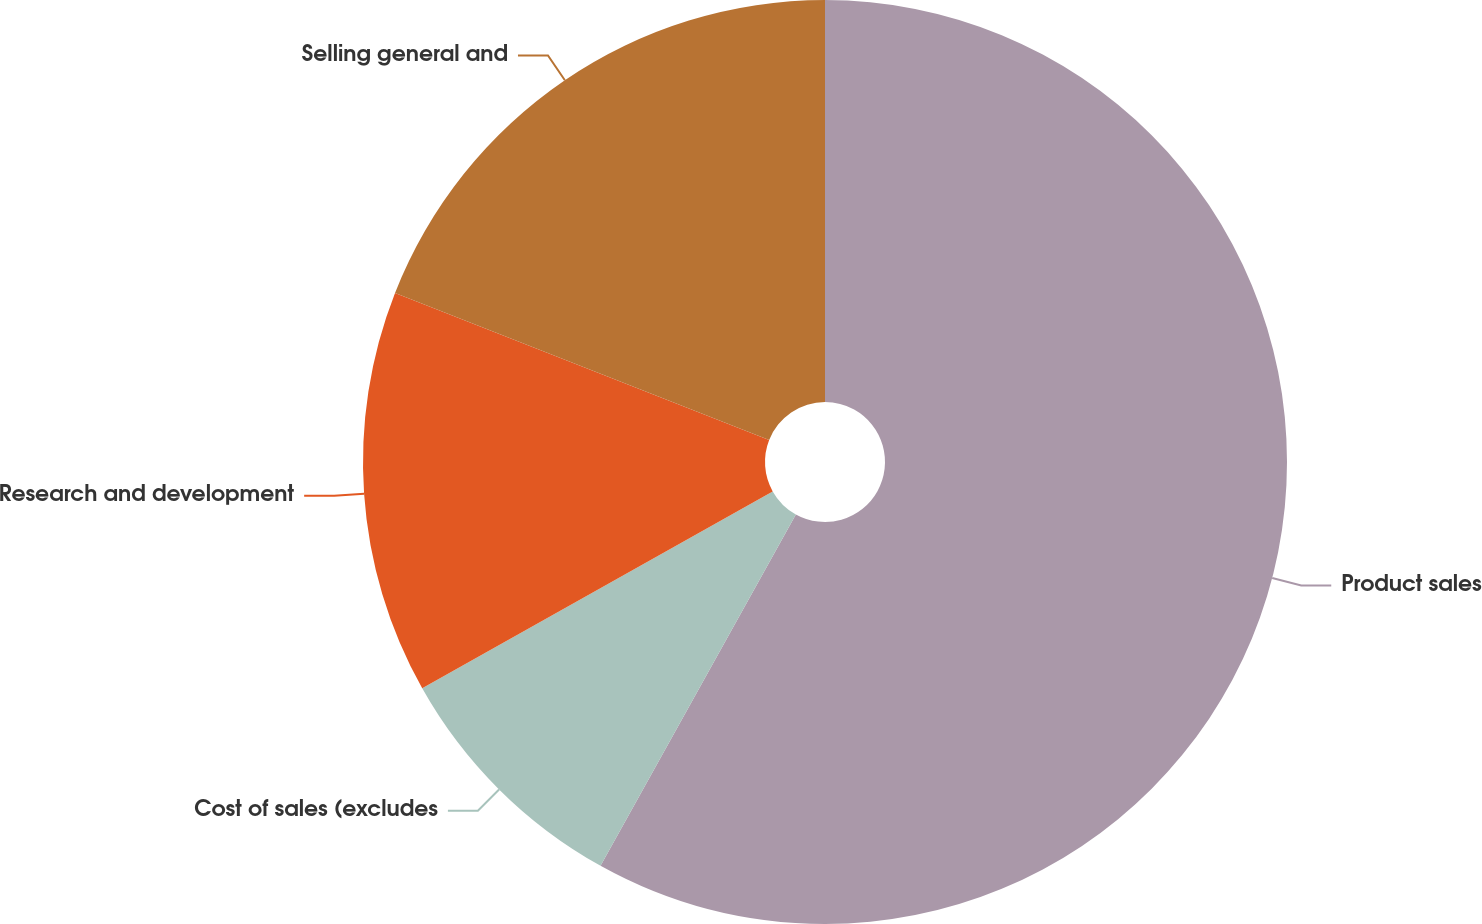Convert chart. <chart><loc_0><loc_0><loc_500><loc_500><pie_chart><fcel>Product sales<fcel>Cost of sales (excludes<fcel>Research and development<fcel>Selling general and<nl><fcel>58.08%<fcel>8.78%<fcel>14.11%<fcel>19.04%<nl></chart> 